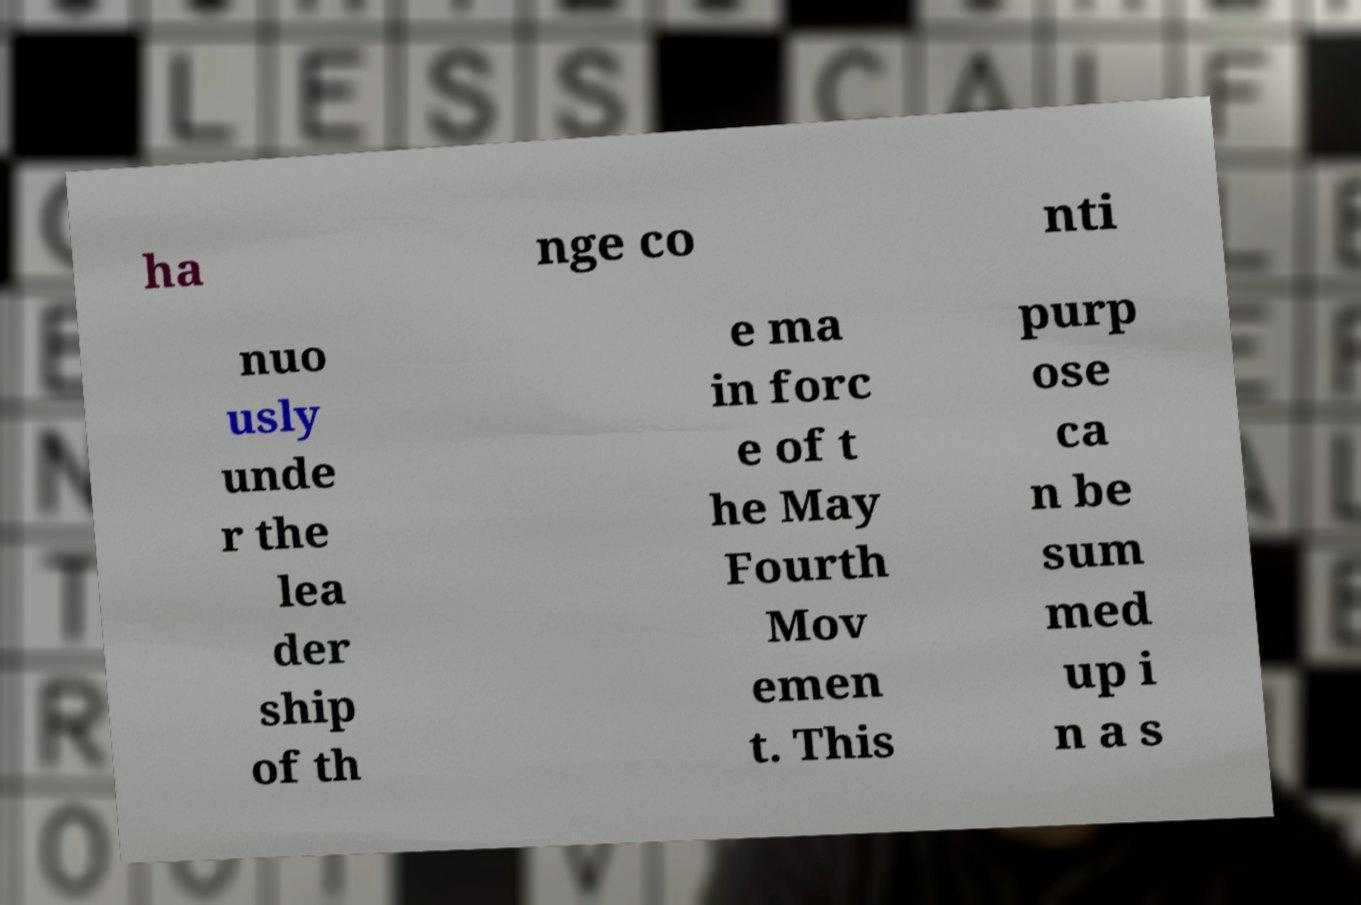I need the written content from this picture converted into text. Can you do that? ha nge co nti nuo usly unde r the lea der ship of th e ma in forc e of t he May Fourth Mov emen t. This purp ose ca n be sum med up i n a s 